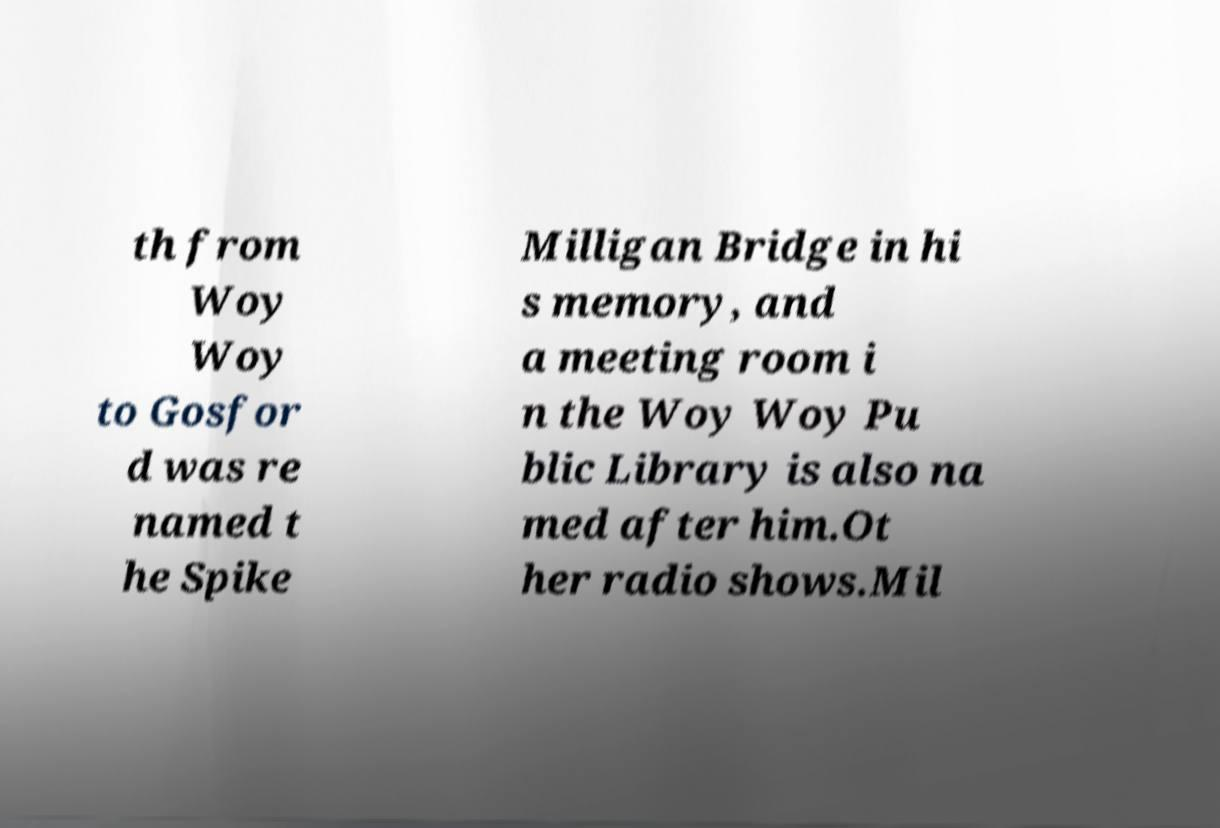There's text embedded in this image that I need extracted. Can you transcribe it verbatim? th from Woy Woy to Gosfor d was re named t he Spike Milligan Bridge in hi s memory, and a meeting room i n the Woy Woy Pu blic Library is also na med after him.Ot her radio shows.Mil 